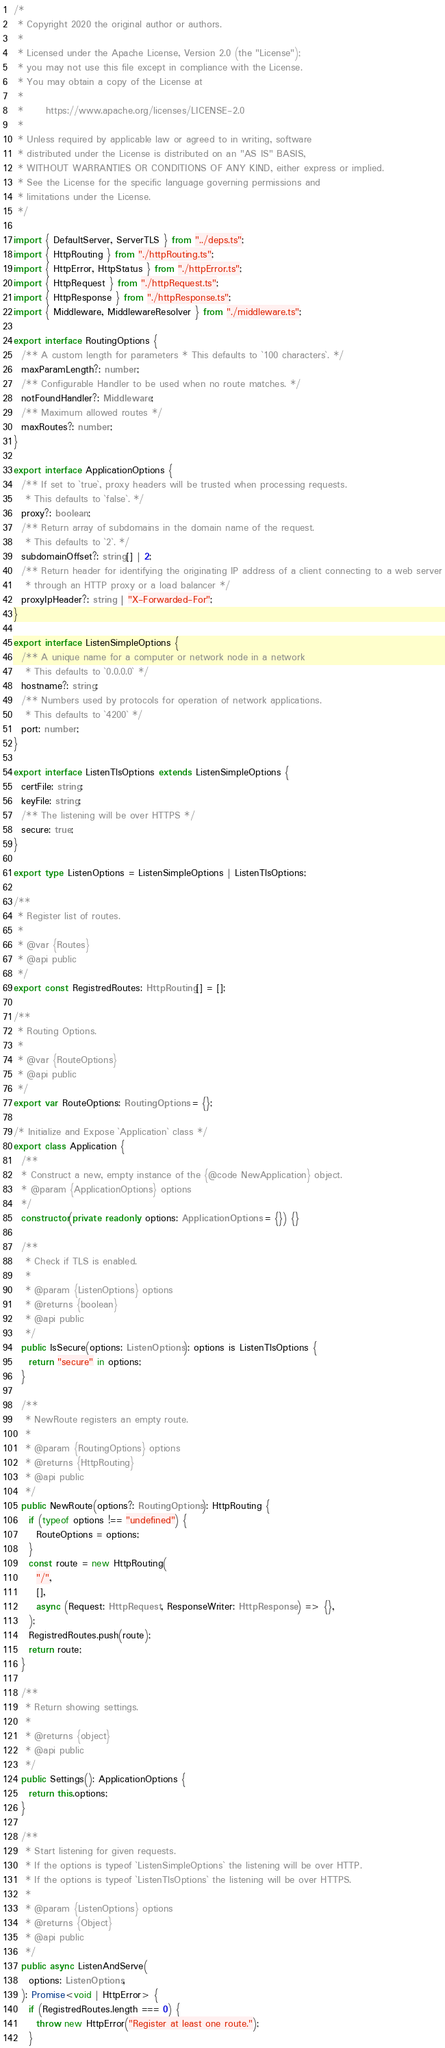Convert code to text. <code><loc_0><loc_0><loc_500><loc_500><_TypeScript_>/*
 * Copyright 2020 the original author or authors.
 *
 * Licensed under the Apache License, Version 2.0 (the "License");
 * you may not use this file except in compliance with the License.
 * You may obtain a copy of the License at
 *
 *      https://www.apache.org/licenses/LICENSE-2.0
 *
 * Unless required by applicable law or agreed to in writing, software
 * distributed under the License is distributed on an "AS IS" BASIS,
 * WITHOUT WARRANTIES OR CONDITIONS OF ANY KIND, either express or implied.
 * See the License for the specific language governing permissions and
 * limitations under the License.
 */

import { DefaultServer, ServerTLS } from "../deps.ts";
import { HttpRouting } from "./httpRouting.ts";
import { HttpError, HttpStatus } from "./httpError.ts";
import { HttpRequest } from "./httpRequest.ts";
import { HttpResponse } from "./httpResponse.ts";
import { Middleware, MiddlewareResolver } from "./middleware.ts";

export interface RoutingOptions {
  /** A custom length for parameters * This defaults to `100 characters`. */
  maxParamLength?: number;
  /** Configurable Handler to be used when no route matches. */
  notFoundHandler?: Middleware;
  /** Maximum allowed routes */
  maxRoutes?: number;
}

export interface ApplicationOptions {
  /** If set to `true`, proxy headers will be trusted when processing requests.
   * This defaults to `false`. */
  proxy?: boolean;
  /** Return array of subdomains in the domain name of the request.
   * This defaults to `2`. */
  subdomainOffset?: string[] | 2;
  /** Return header for identifying the originating IP address of a client connecting to a web server
   * through an HTTP proxy or a load balancer */
  proxyIpHeader?: string | "X-Forwarded-For";
}

export interface ListenSimpleOptions {
  /** A unique name for a computer or network node in a network
   * This defaults to `0.0.0.0` */
  hostname?: string;
  /** Numbers used by protocols for operation of network applications.
   * This defaults to `4200` */
  port: number;
}

export interface ListenTlsOptions extends ListenSimpleOptions {
  certFile: string;
  keyFile: string;
  /** The listening will be over HTTPS */
  secure: true;
}

export type ListenOptions = ListenSimpleOptions | ListenTlsOptions;

/**
 * Register list of routes.
 *
 * @var {Routes}
 * @api public
 */
export const RegistredRoutes: HttpRouting[] = [];

/**
 * Routing Options.
 *
 * @var {RouteOptions}
 * @api public
 */
export var RouteOptions: RoutingOptions = {};

/* Initialize and Expose `Application` class */
export class Application {
  /**
  * Construct a new, empty instance of the {@code NewApplication} object.
  * @param {ApplicationOptions} options
  */
  constructor(private readonly options: ApplicationOptions = {}) {}

  /**
   * Check if TLS is enabled.
   *
   * @param {ListenOptions} options
   * @returns {boolean}
   * @api public
   */
  public IsSecure(options: ListenOptions): options is ListenTlsOptions {
    return "secure" in options;
  }

  /**
   * NewRoute registers an empty route.
   *
   * @param {RoutingOptions} options
   * @returns {HttpRouting}
   * @api public
   */
  public NewRoute(options?: RoutingOptions): HttpRouting {
    if (typeof options !== "undefined") {
      RouteOptions = options;
    }
    const route = new HttpRouting(
      "/",
      [],
      async (Request: HttpRequest, ResponseWriter: HttpResponse) => {},
    );
    RegistredRoutes.push(route);
    return route;
  }

  /**
   * Return showing settings.
   *
   * @returns {object}
   * @api public
   */
  public Settings(): ApplicationOptions {
    return this.options;
  }

  /**
   * Start listening for given requests.
   * If the options is typeof `ListenSimpleOptions` the listening will be over HTTP.
   * If the options is typeof `ListenTlsOptions` the listening will be over HTTPS.
   *
   * @param {ListenOptions} options
   * @returns {Object}
   * @api public
   */
  public async ListenAndServe(
    options: ListenOptions,
  ): Promise<void | HttpError> {
    if (RegistredRoutes.length === 0) {
      throw new HttpError("Register at least one route.");
    }</code> 